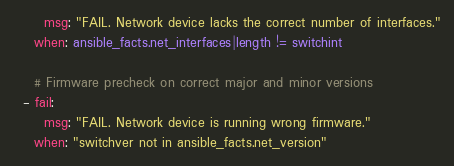<code> <loc_0><loc_0><loc_500><loc_500><_YAML_>      msg: "FAIL. Network device lacks the correct number of interfaces."
    when: ansible_facts.net_interfaces|length != switchint

    # Firmware precheck on correct major and minor versions
  - fail:
      msg: "FAIL. Network device is running wrong firmware."
    when: "switchver not in ansible_facts.net_version"

</code> 